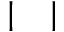<formula> <loc_0><loc_0><loc_500><loc_500>| \quad |</formula> 